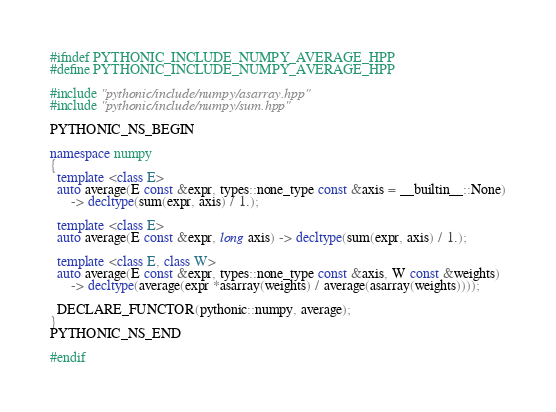Convert code to text. <code><loc_0><loc_0><loc_500><loc_500><_C++_>#ifndef PYTHONIC_INCLUDE_NUMPY_AVERAGE_HPP
#define PYTHONIC_INCLUDE_NUMPY_AVERAGE_HPP

#include "pythonic/include/numpy/asarray.hpp"
#include "pythonic/include/numpy/sum.hpp"

PYTHONIC_NS_BEGIN

namespace numpy
{
  template <class E>
  auto average(E const &expr, types::none_type const &axis = __builtin__::None)
      -> decltype(sum(expr, axis) / 1.);

  template <class E>
  auto average(E const &expr, long axis) -> decltype(sum(expr, axis) / 1.);

  template <class E, class W>
  auto average(E const &expr, types::none_type const &axis, W const &weights)
      -> decltype(average(expr *asarray(weights) / average(asarray(weights))));

  DECLARE_FUNCTOR(pythonic::numpy, average);
}
PYTHONIC_NS_END

#endif
</code> 